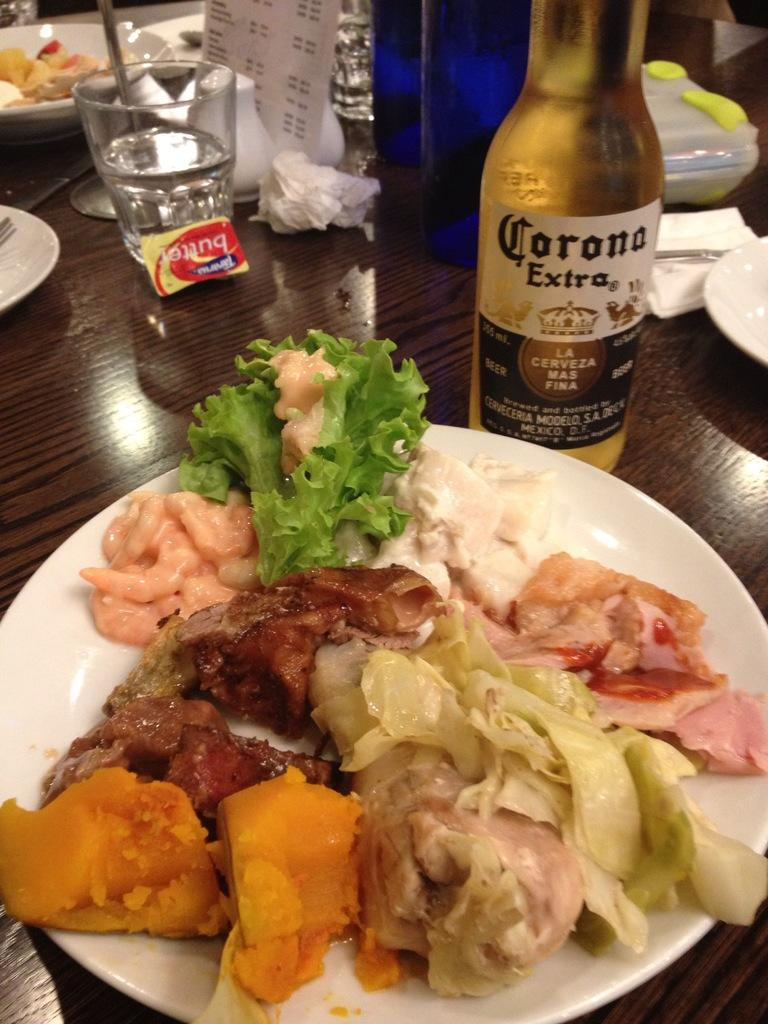Provide a one-sentence caption for the provided image. Plate with food including a bottle that says Corona on it. 